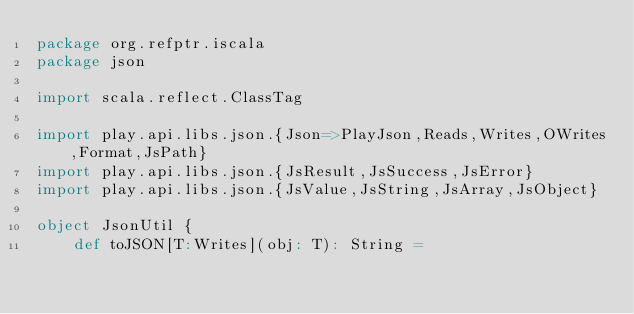Convert code to text. <code><loc_0><loc_0><loc_500><loc_500><_Scala_>package org.refptr.iscala
package json

import scala.reflect.ClassTag

import play.api.libs.json.{Json=>PlayJson,Reads,Writes,OWrites,Format,JsPath}
import play.api.libs.json.{JsResult,JsSuccess,JsError}
import play.api.libs.json.{JsValue,JsString,JsArray,JsObject}

object JsonUtil {
    def toJSON[T:Writes](obj: T): String =</code> 